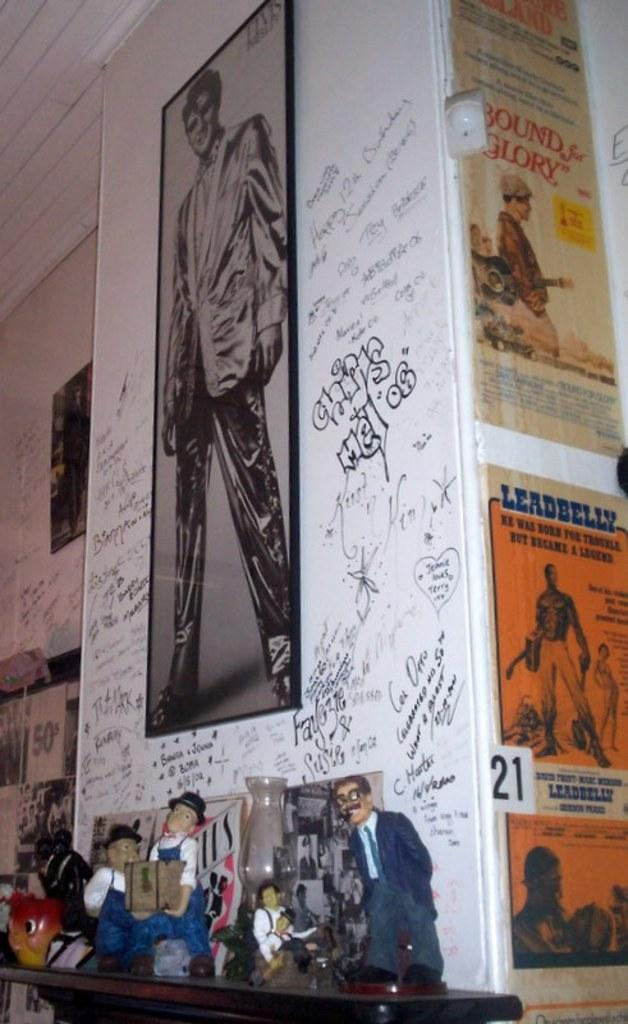Provide a one-sentence caption for the provided image. A fireplace mantle with dolls on it and graffiti on the wall and a poster for Bound for Glory. 